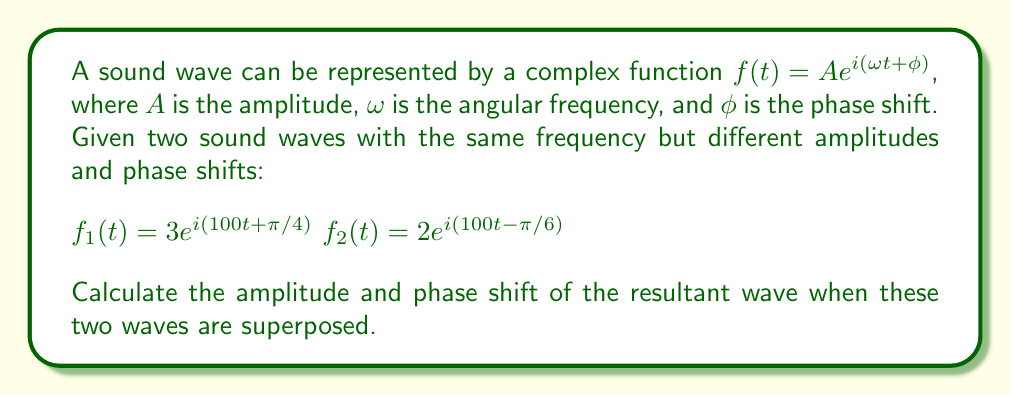Give your solution to this math problem. To solve this problem, we'll follow these steps:

1) The superposition of two waves is the sum of their complex representations:
   $f_{resultant}(t) = f_1(t) + f_2(t)$

2) Substitute the given functions:
   $f_{resultant}(t) = 3e^{i(100t + π/4)} + 2e^{i(100t - π/6)}$

3) Factor out the common $e^{i100t}$:
   $f_{resultant}(t) = e^{i100t}(3e^{iπ/4} + 2e^{-iπ/6})$

4) Let's focus on the term in parentheses. We can represent these complex numbers in polar form:
   $3e^{iπ/4} = 3(\cos(π/4) + i\sin(π/4)) = 3(0.707 + 0.707i)$
   $2e^{-iπ/6} = 2(\cos(-π/6) + i\sin(-π/6)) = 2(0.866 - 0.5i)$

5) Add these complex numbers:
   $3(0.707 + 0.707i) + 2(0.866 - 0.5i) = 2.121 + 2.121i + 1.732 - i = 3.853 + 1.121i$

6) Convert this result back to polar form:
   $r = \sqrt{3.853^2 + 1.121^2} = 4.013$
   $θ = \tan^{-1}(1.121/3.853) = 0.283$ radians

7) Therefore, the resultant wave can be written as:
   $f_{resultant}(t) = 4.013e^{i(100t + 0.283)}$

8) Comparing this to the general form $Ae^{i(ωt + φ)}$, we can identify:
   Amplitude $A = 4.013$
   Phase shift $φ = 0.283$ radians
Answer: Amplitude: 4.013, Phase shift: 0.283 radians 